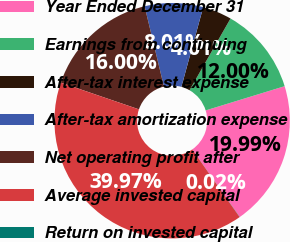Convert chart to OTSL. <chart><loc_0><loc_0><loc_500><loc_500><pie_chart><fcel>Year Ended December 31<fcel>Earnings from continuing<fcel>After-tax interest expense<fcel>After-tax amortization expense<fcel>Net operating profit after<fcel>Average invested capital<fcel>Return on invested capital<nl><fcel>19.99%<fcel>12.0%<fcel>4.01%<fcel>8.01%<fcel>16.0%<fcel>39.97%<fcel>0.02%<nl></chart> 